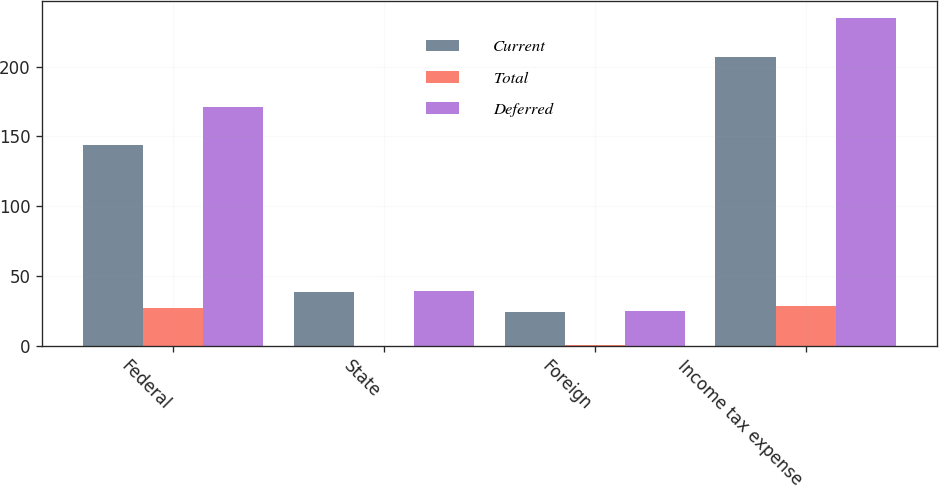Convert chart. <chart><loc_0><loc_0><loc_500><loc_500><stacked_bar_chart><ecel><fcel>Federal<fcel>State<fcel>Foreign<fcel>Income tax expense<nl><fcel>Current<fcel>143.8<fcel>38.8<fcel>24.1<fcel>206.7<nl><fcel>Total<fcel>27.4<fcel>0.2<fcel>0.8<fcel>28.4<nl><fcel>Deferred<fcel>171.2<fcel>39<fcel>24.9<fcel>235.1<nl></chart> 